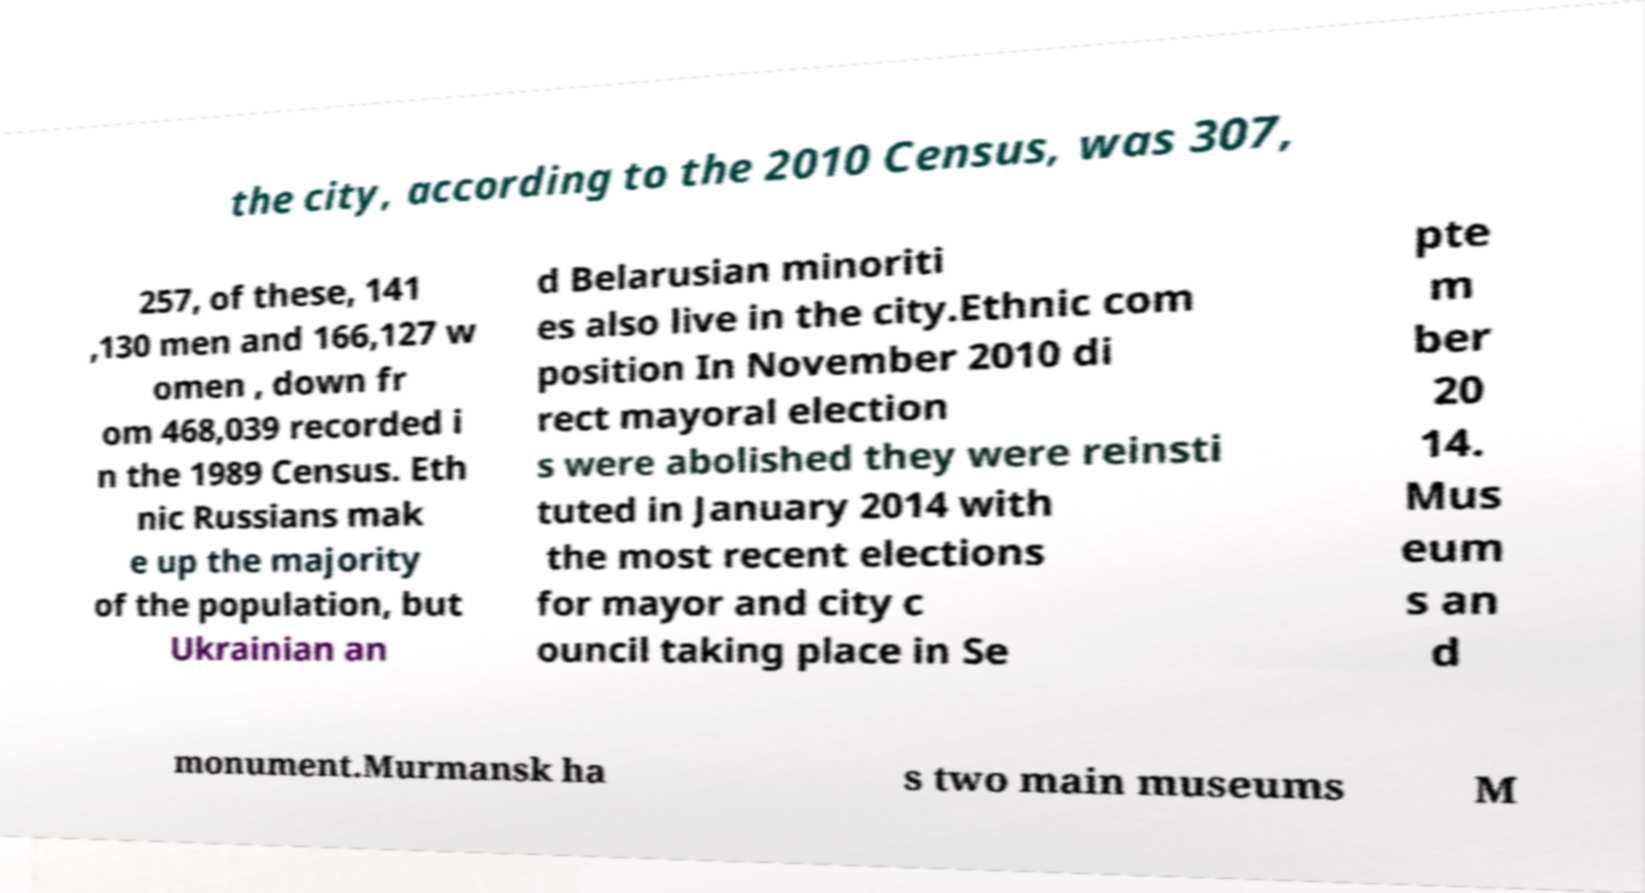For documentation purposes, I need the text within this image transcribed. Could you provide that? the city, according to the 2010 Census, was 307, 257, of these, 141 ,130 men and 166,127 w omen , down fr om 468,039 recorded i n the 1989 Census. Eth nic Russians mak e up the majority of the population, but Ukrainian an d Belarusian minoriti es also live in the city.Ethnic com position In November 2010 di rect mayoral election s were abolished they were reinsti tuted in January 2014 with the most recent elections for mayor and city c ouncil taking place in Se pte m ber 20 14. Mus eum s an d monument.Murmansk ha s two main museums M 